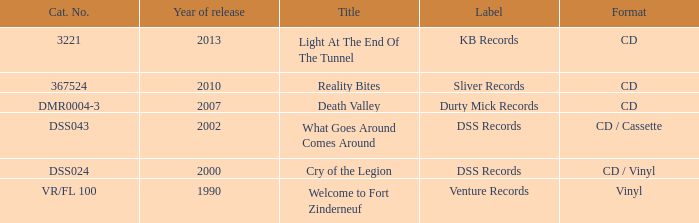What is the total year of release of the title what goes around comes around? 1.0. 